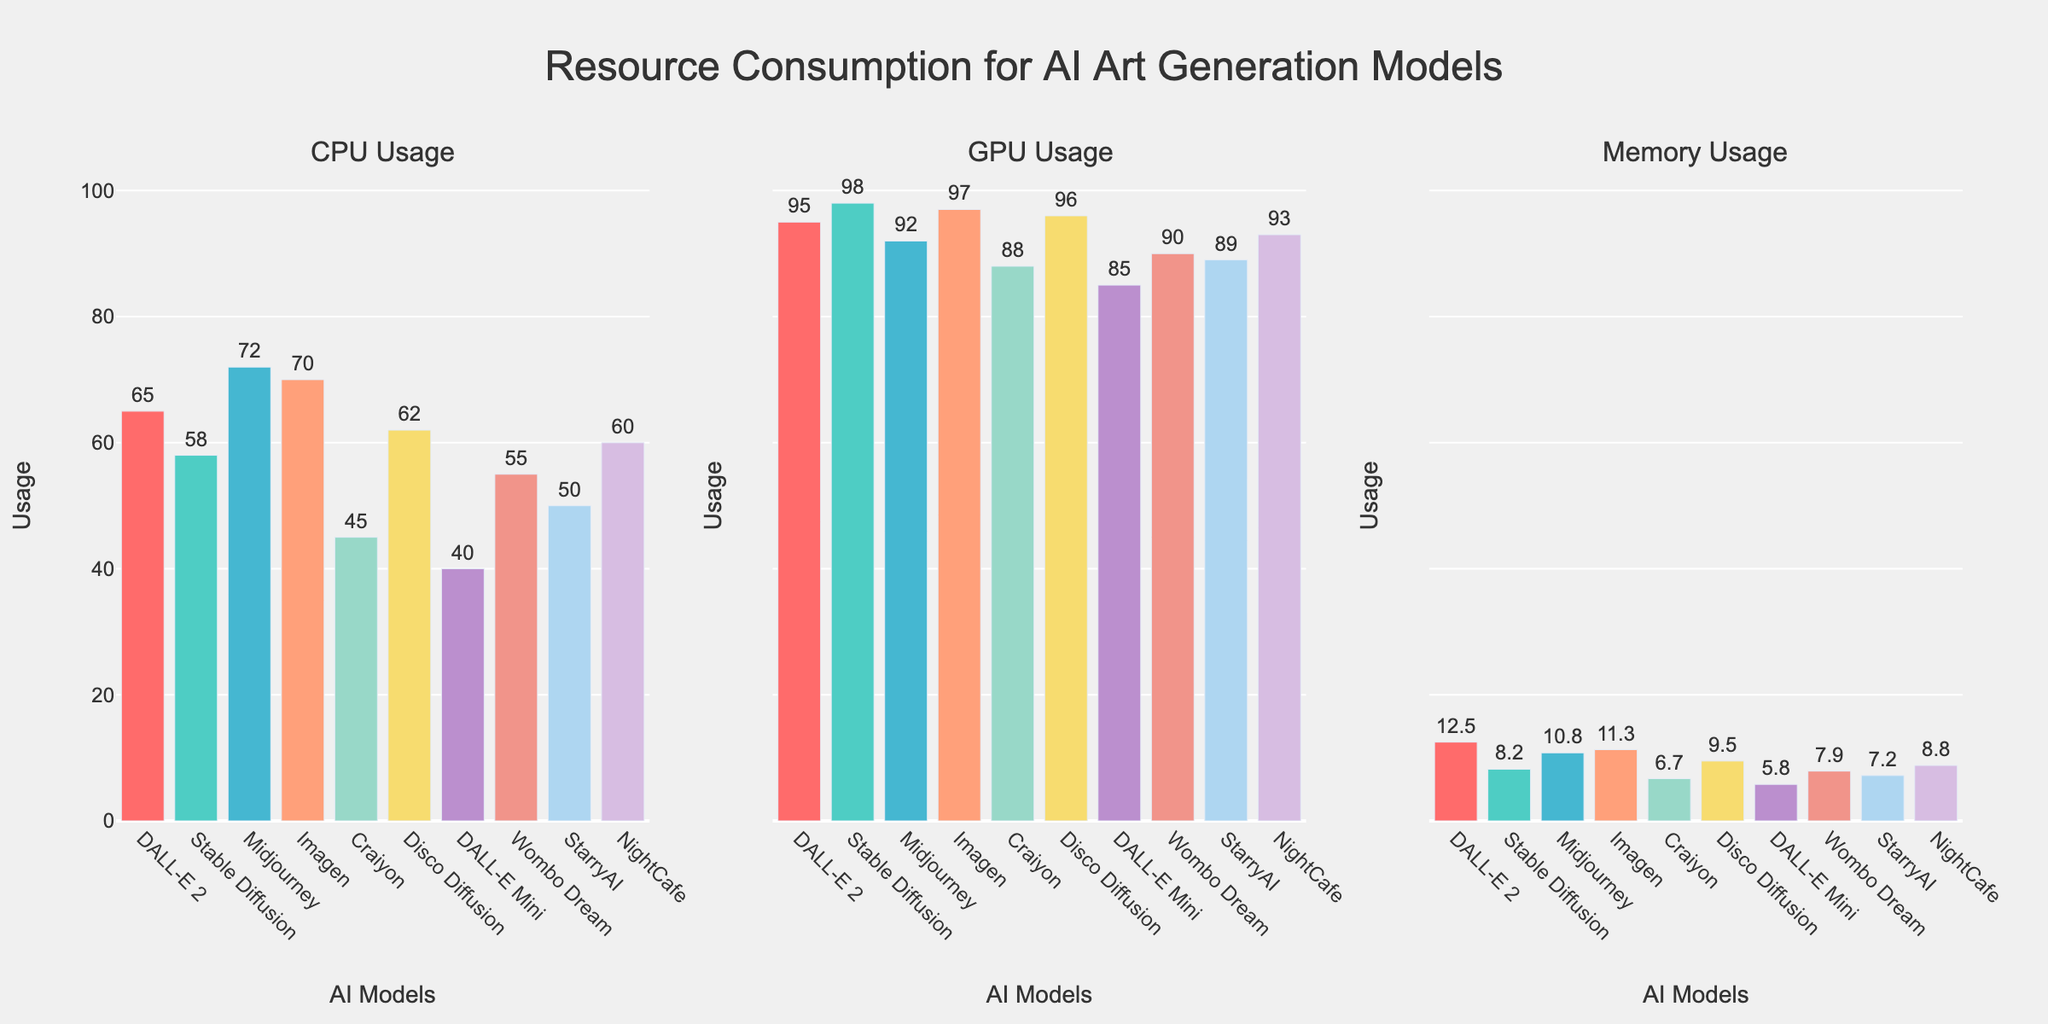What is the title of the figure? The title is located at the top of the figure, centered, and slightly above the plots. It reads "Resource Consumption for AI Art Generation Models," indicating the main focus of this figure is the consumption of different resources (CPU, GPU, Memory) for various AI art generation models.
Answer: Resource Consumption for AI Art Generation Models Which AI model has the highest CPU usage? To find the AI model with the highest CPU usage, refer to the first subplot under "CPU Usage." The tallest bar corresponds to the "Midjourney" model.
Answer: Midjourney What is the CPU usage percentage of DALL-E 2? The first subplot (CPU Usage) shows the CPU usage percentages of all models. Find the bar labeled "DALL-E 2" and check the value positioned outside the bar.
Answer: 65% Which model uses the least memory? To determine this, look at the third subplot titled "Memory Usage." The shortest bar represents the model with the least memory usage, which is "DALL-E Mini."
Answer: DALL-E Mini What is the difference in GPU usage between Stable Diffusion and Craiyon? Locate both models in the second subplot titled "GPU Usage." Note the values: Stable Diffusion (98%) and Craiyon (88%). Subtract the smaller value from the larger value: 98% - 88% = 10%.
Answer: 10% What is the average memory usage across all AI models? Sum all the memory usage values found in the third subplot: 12.5 + 8.2 + 10.8 + 11.3 + 6.7 + 9.5 + 5.8 + 7.9 + 7.2 + 8.8 = 88.7 GB. Divide by the number of models (10): 88.7 / 10 = 8.87 GB.
Answer: 8.87 GB Which two models have the closest CPU usage percentage? Compare the CPU usage percentages in the first subplot. "Disco Diffusion" and "DALL-E 2" have close values: Disco Diffusion (62%) and DALL-E 2 (65%), with only a 3% difference.
Answer: Disco Diffusion and DALL-E 2 How does CPU usage compare between Wombo Dream and NightCafe? Find both models in the first subplot. Wombo Dream has a CPU usage of 55%, and NightCafe has a CPU usage of 60%. NightCafe's usage is 5% higher than Wombo Dream.
Answer: NightCafe uses 5% more Which model has the highest overall resource consumption considering CPU, GPU, and Memory Usage combined? Sum the values of all resources for each model. For example, DALL-E 2: 65 + 95 + 12.5 = 172.5. Do this for all models and compare the totals. The highest combined total is for "Stable Diffusion": 58 (CPU) + 98 (GPU) + 8.2 (Memory) = 164.2.
Answer: DALL-E 2 